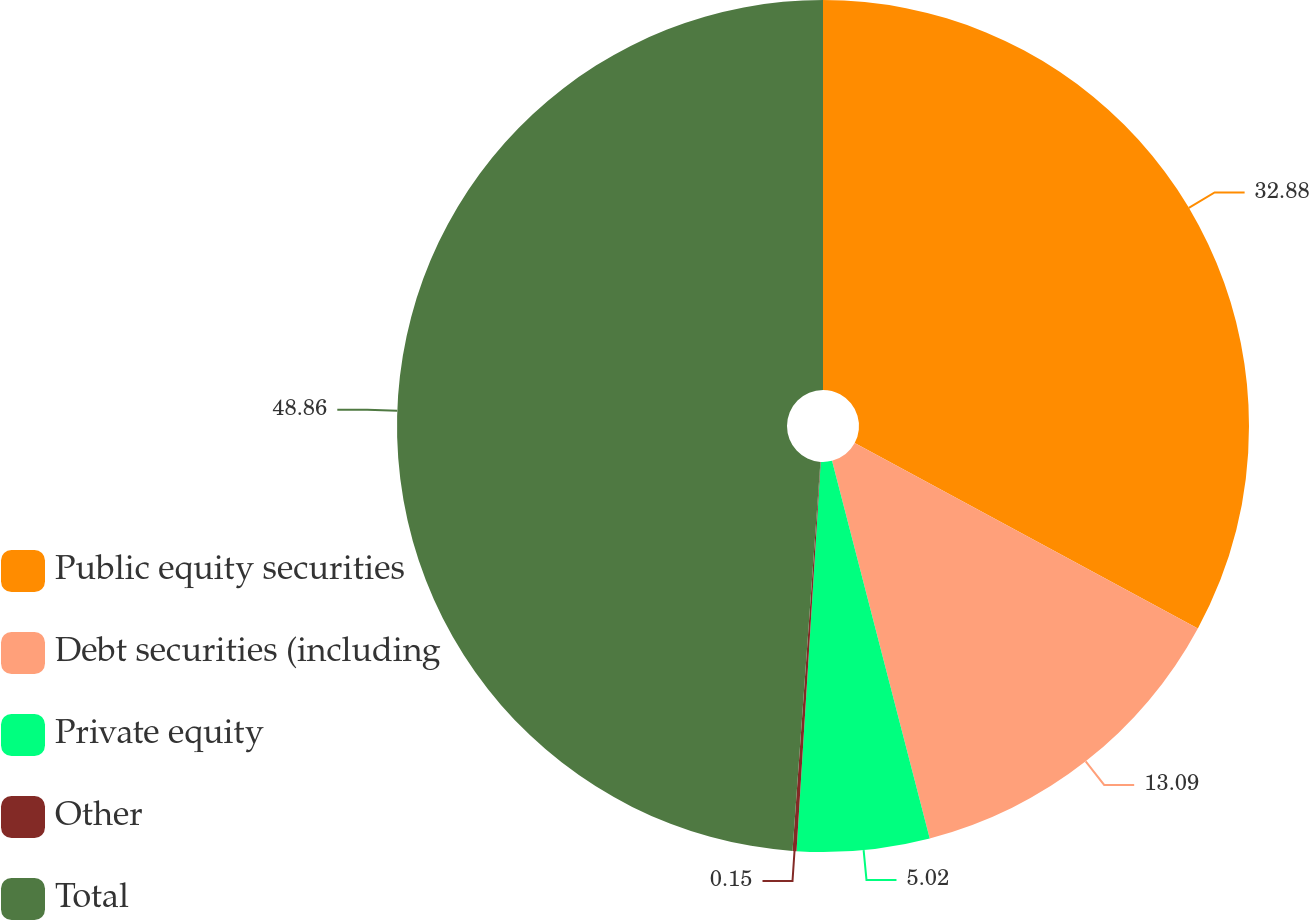Convert chart to OTSL. <chart><loc_0><loc_0><loc_500><loc_500><pie_chart><fcel>Public equity securities<fcel>Debt securities (including<fcel>Private equity<fcel>Other<fcel>Total<nl><fcel>32.88%<fcel>13.09%<fcel>5.02%<fcel>0.15%<fcel>48.86%<nl></chart> 